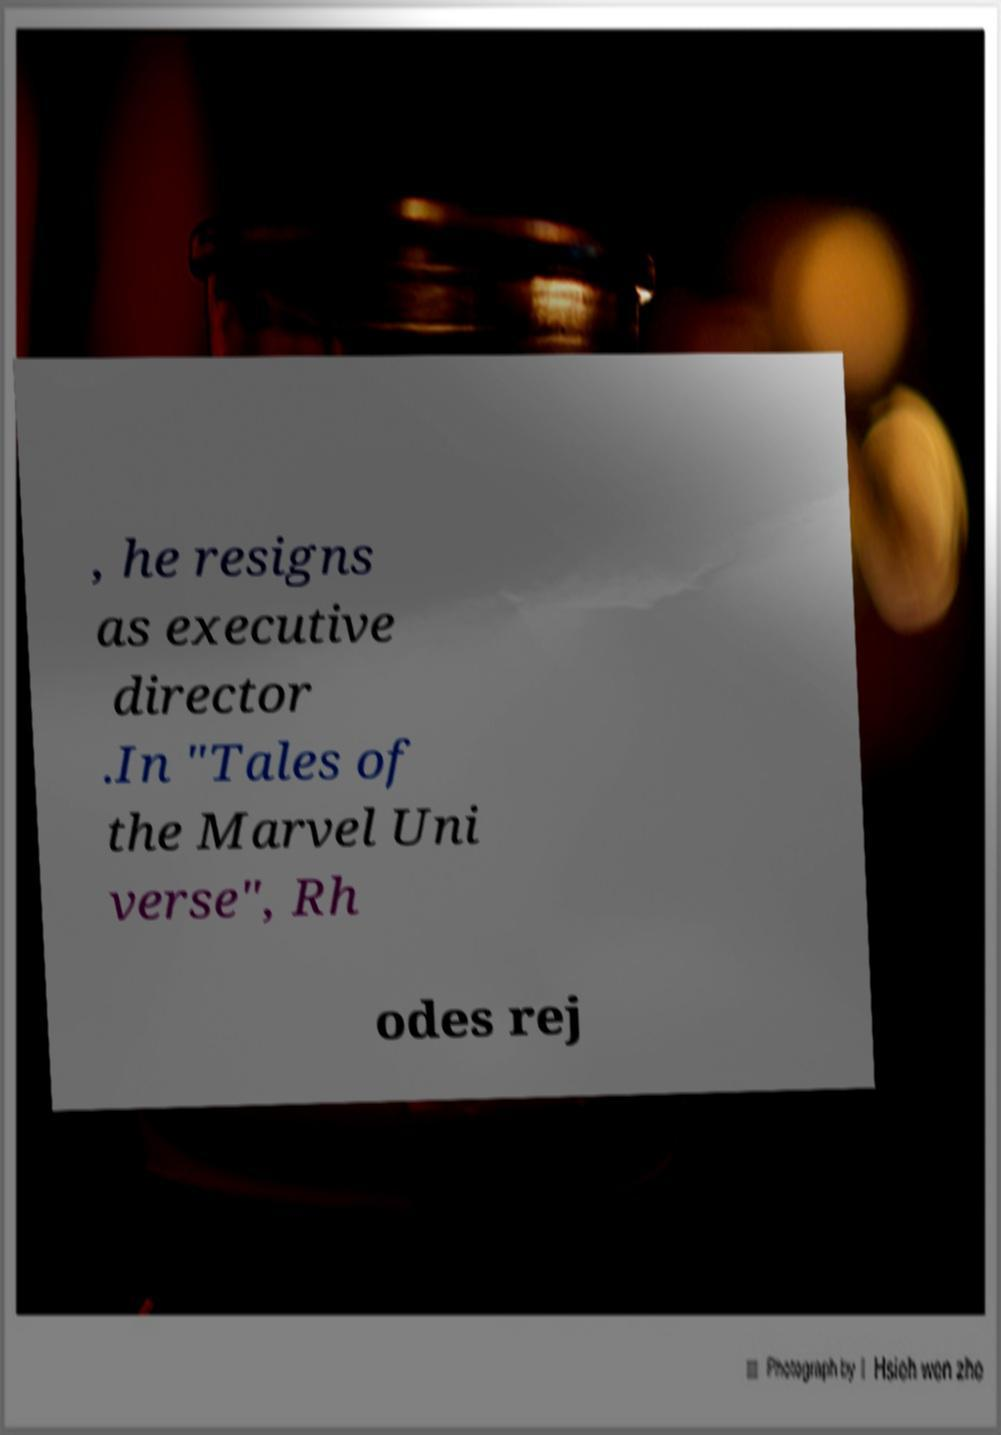Please identify and transcribe the text found in this image. , he resigns as executive director .In "Tales of the Marvel Uni verse", Rh odes rej 